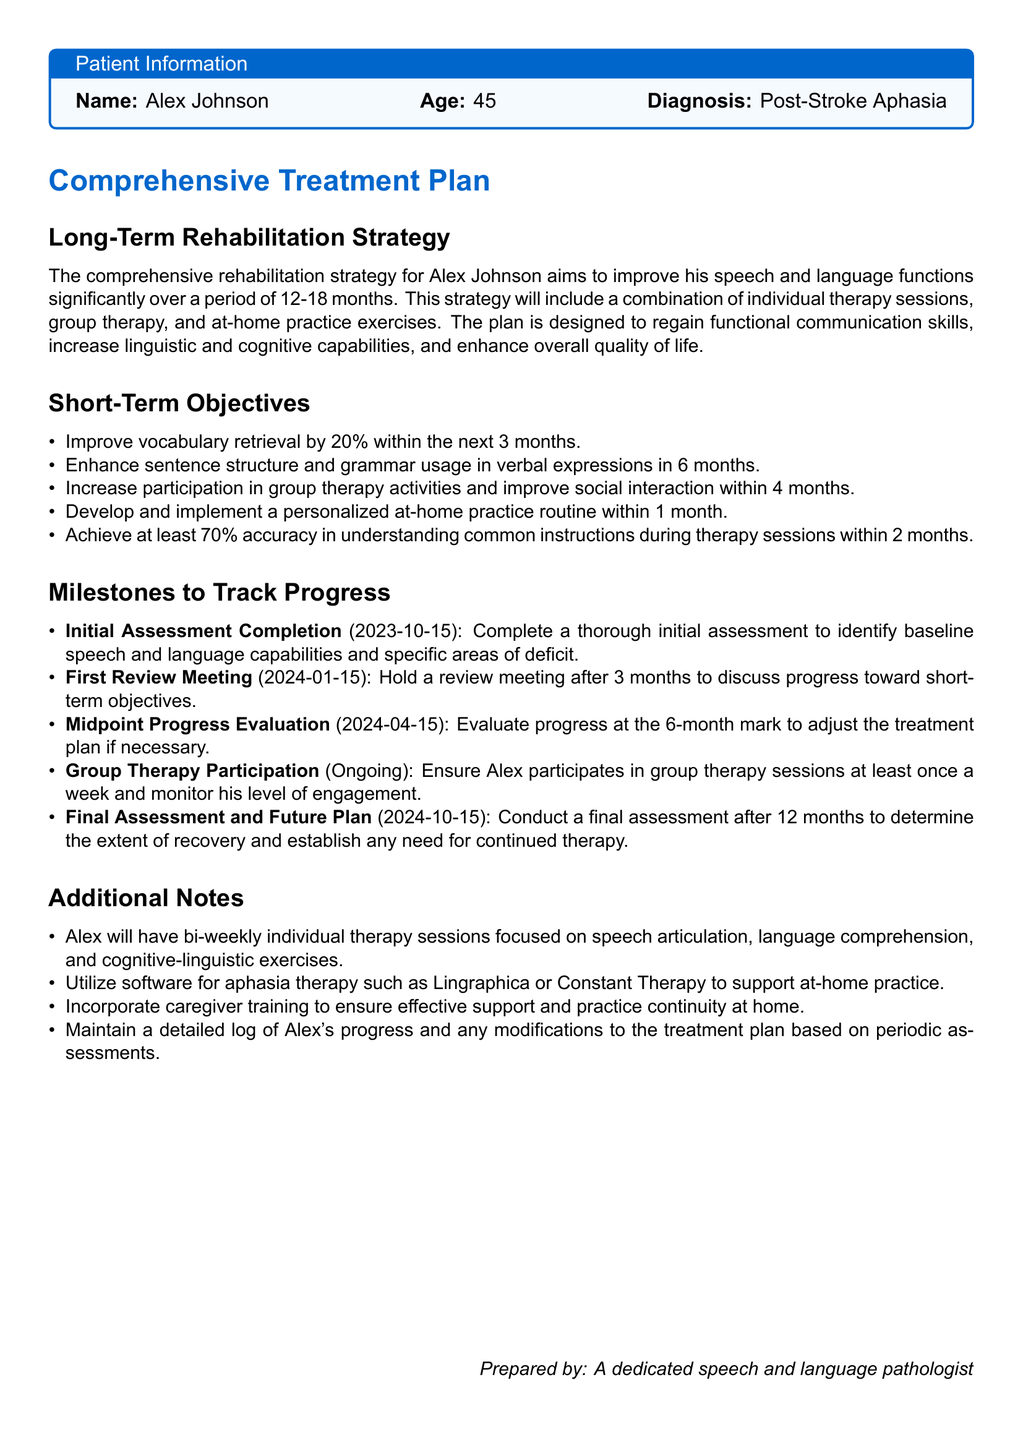What is the patient's name? The patient's name is stated in the patient information section of the document.
Answer: Alex Johnson What is the diagnosis mentioned for Alex Johnson? The diagnosis can be found in the patient information box that outlines the patient's medical condition.
Answer: Post-Stroke Aphasia What is the period for the long-term rehabilitation strategy? The period for the long-term rehabilitation strategy is suggested within the long-term strategy section.
Answer: 12-18 months How much improvement in vocabulary retrieval is targeted within the next 3 months? The targeted improvement detail is given in the short-term objectives section outlining specific goals.
Answer: 20% When is the final assessment scheduled? The date for the final assessment is listed under milestones to track progress.
Answer: 2024-10-15 What type of therapy sessions will Alex have? The type of therapy sessions is detailed in the additional notes section regarding therapy formats.
Answer: Bi-weekly individual therapy sessions What is one software suggested for at-home practice? The document mentions specific software in the additional notes for therapy support.
Answer: Lingraphica How often should Alex participate in group therapy sessions? The frequency of group therapy participation is specified in the milestones section for tracking progress.
Answer: At least once a week 